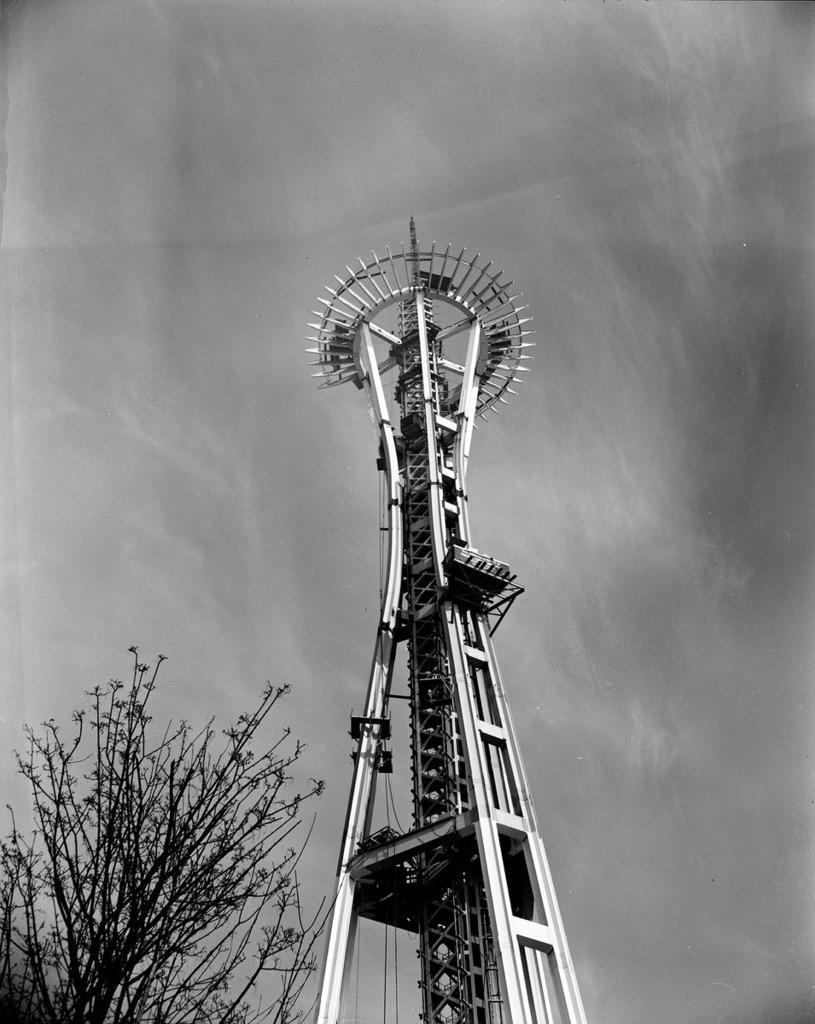What is the color scheme of the image? The image is black and white. What can be seen in the sky in the image? There is a sky visible in the image. What structure is present in the image? There is a tower in the image. What type of vegetation is on the left side of the image? There is a tree on the left side of the image. What type of meal is being prepared in the image? There is no meal preparation visible in the image. What scent can be detected in the image? There is no mention of any scent in the image. 